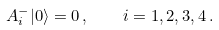Convert formula to latex. <formula><loc_0><loc_0><loc_500><loc_500>A _ { i } ^ { - } | 0 \rangle = 0 \, , \quad i = 1 , 2 , 3 , 4 \, .</formula> 